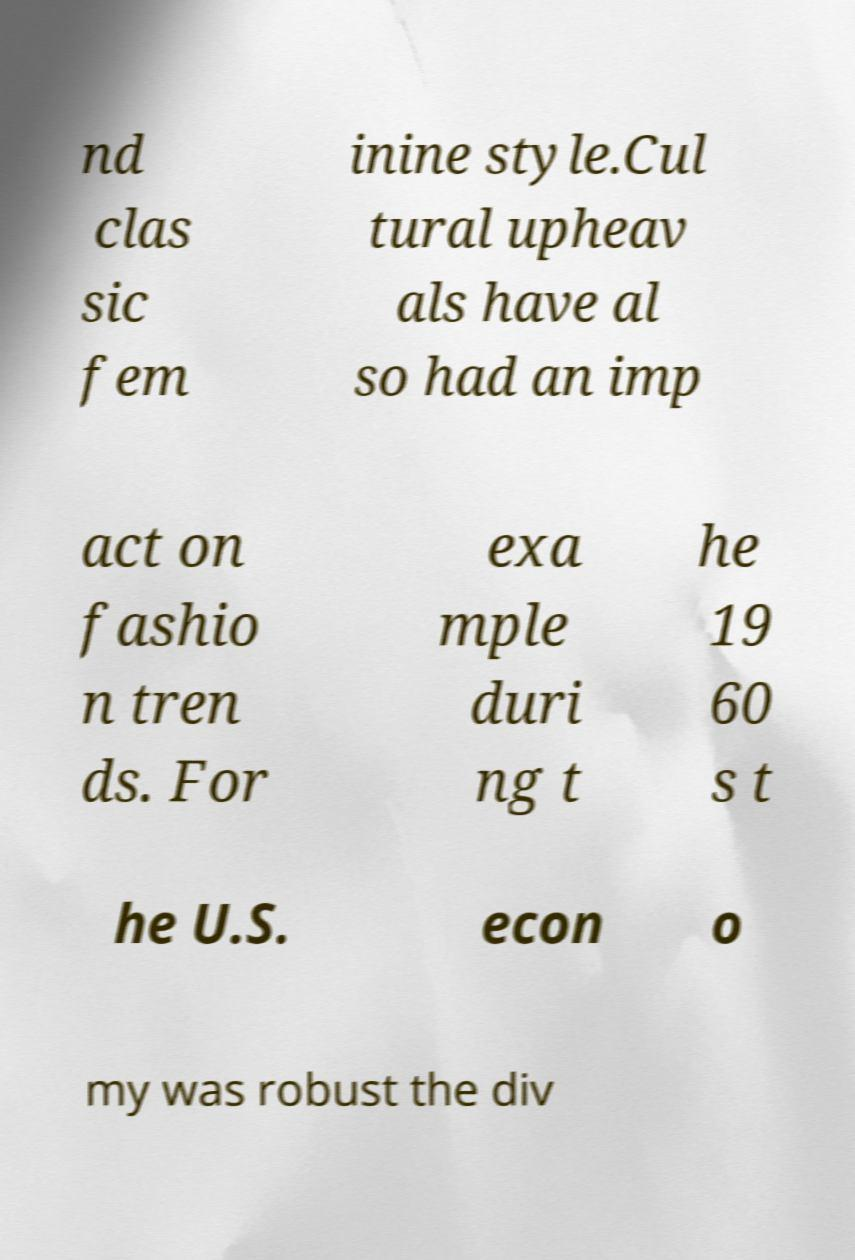Please read and relay the text visible in this image. What does it say? nd clas sic fem inine style.Cul tural upheav als have al so had an imp act on fashio n tren ds. For exa mple duri ng t he 19 60 s t he U.S. econ o my was robust the div 